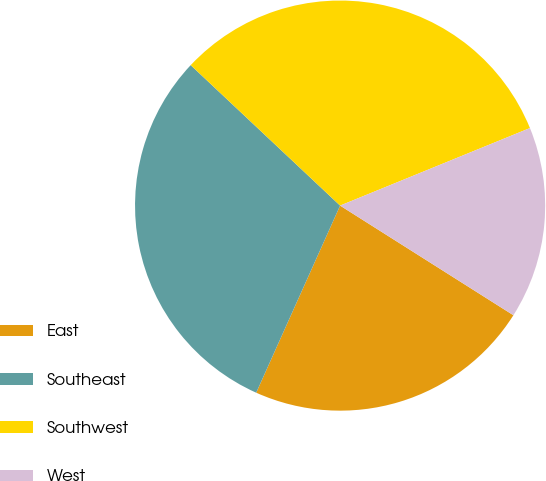Convert chart to OTSL. <chart><loc_0><loc_0><loc_500><loc_500><pie_chart><fcel>East<fcel>Southeast<fcel>Southwest<fcel>West<nl><fcel>22.73%<fcel>30.3%<fcel>31.82%<fcel>15.15%<nl></chart> 